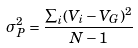<formula> <loc_0><loc_0><loc_500><loc_500>\sigma _ { P } ^ { 2 } = \frac { \sum _ { i } ( V _ { i } - V _ { G } ) ^ { 2 } } { N - 1 }</formula> 